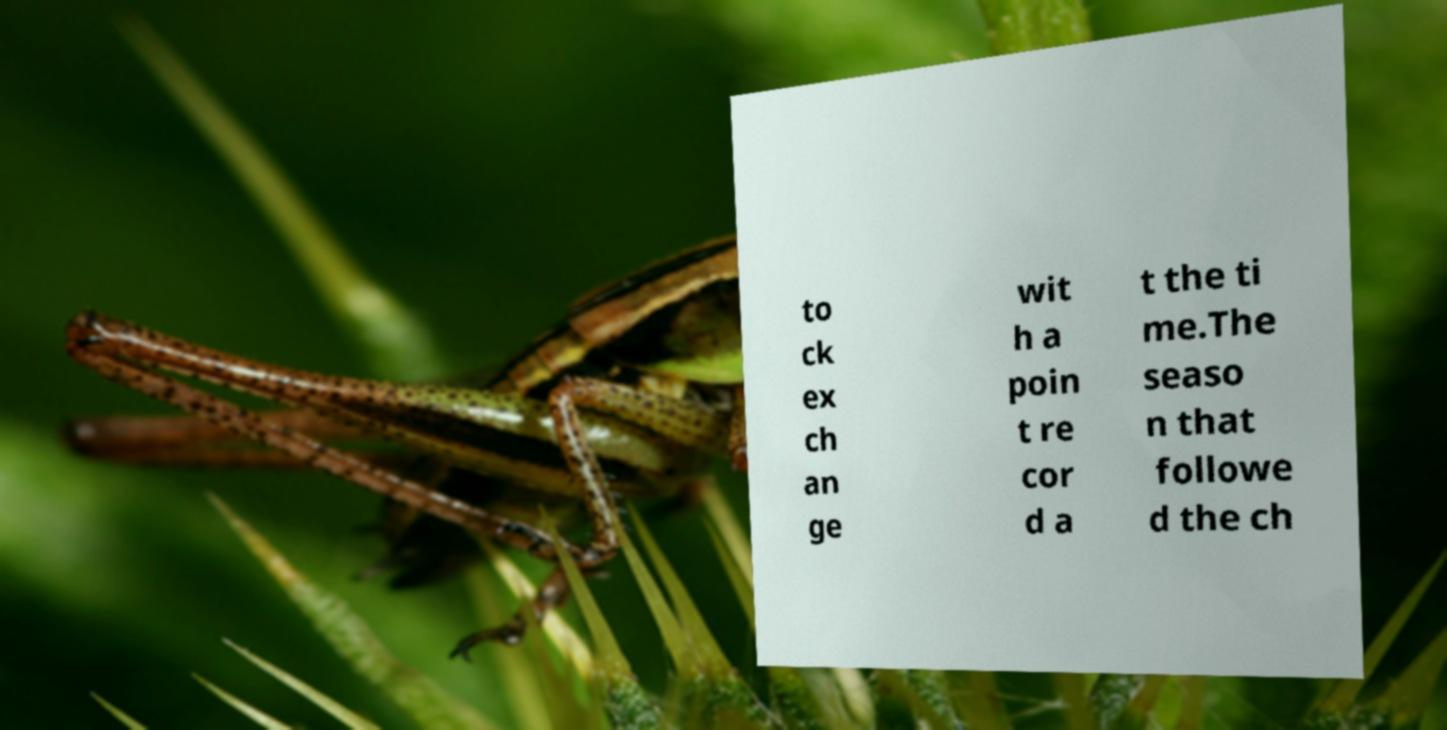Could you extract and type out the text from this image? to ck ex ch an ge wit h a poin t re cor d a t the ti me.The seaso n that followe d the ch 